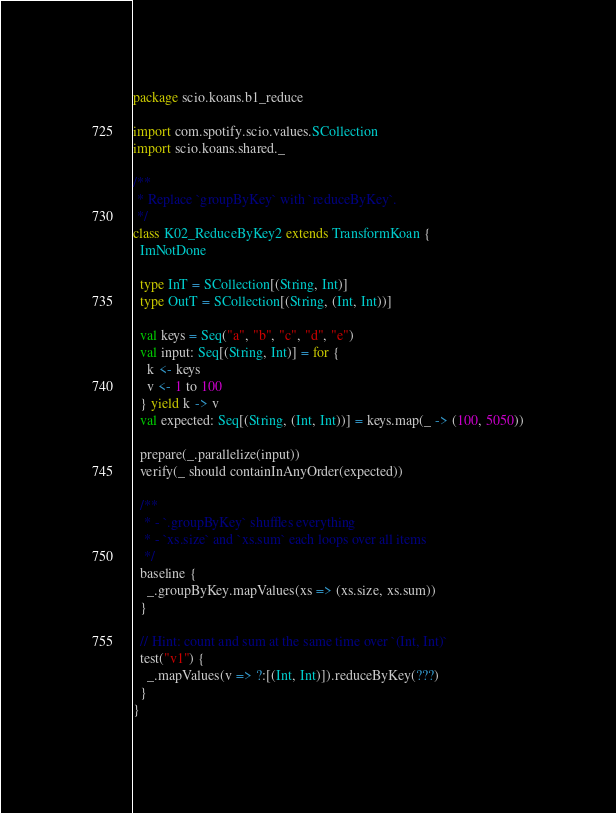Convert code to text. <code><loc_0><loc_0><loc_500><loc_500><_Scala_>package scio.koans.b1_reduce

import com.spotify.scio.values.SCollection
import scio.koans.shared._

/**
 * Replace `groupByKey` with `reduceByKey`.
 */
class K02_ReduceByKey2 extends TransformKoan {
  ImNotDone

  type InT = SCollection[(String, Int)]
  type OutT = SCollection[(String, (Int, Int))]

  val keys = Seq("a", "b", "c", "d", "e")
  val input: Seq[(String, Int)] = for {
    k <- keys
    v <- 1 to 100
  } yield k -> v
  val expected: Seq[(String, (Int, Int))] = keys.map(_ -> (100, 5050))

  prepare(_.parallelize(input))
  verify(_ should containInAnyOrder(expected))

  /**
   * - `.groupByKey` shuffles everything
   * - `xs.size` and `xs.sum` each loops over all items
   */
  baseline {
    _.groupByKey.mapValues(xs => (xs.size, xs.sum))
  }

  // Hint: count and sum at the same time over `(Int, Int)`
  test("v1") {
    _.mapValues(v => ?:[(Int, Int)]).reduceByKey(???)
  }
}
</code> 